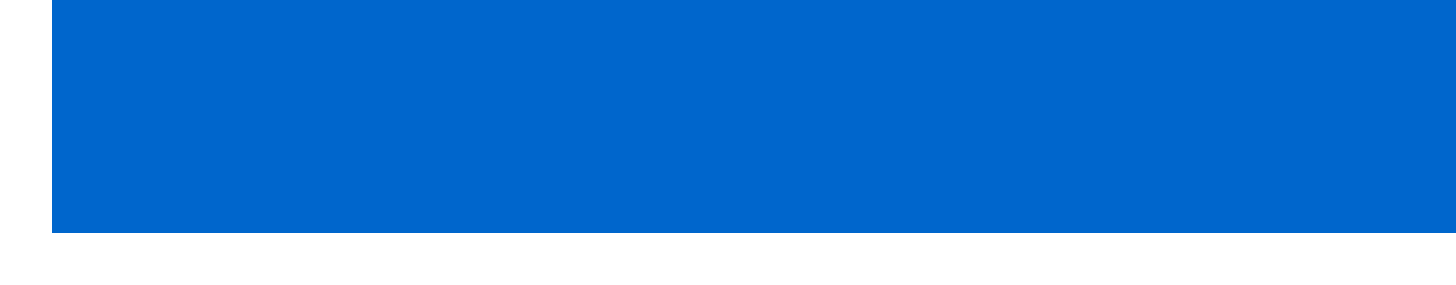What is the date of the meeting? The meeting took place on May 15, 2023.
Answer: May 15, 2023 Who is the chair of the meeting? The chair of the meeting is Jake Sullivan.
Answer: Jake Sullivan What are the team name suggestions discussed? The team name suggestions mentioned are 'Homerun Heroes' or 'Alma Mater Sluggers'.
Answer: 'Homerun Heroes' or 'Alma Mater Sluggers' What is the fundraising goal for the first year? The document states that the fundraising goal for the first year is $10,000.
Answer: $10,000 Who is responsible for creating social media accounts for the team? The document indicates that Emily Rodriguez is assigned to create social media accounts for the team.
Answer: Emily Rodriguez What is the projected annual expense for the team? The document mentions projected annual expenses amounting to $5,000.
Answer: $5,000 When is the next meeting scheduled? According to the document, the next meeting is scheduled for June 5, 2023.
Answer: June 5, 2023 What is one of the fundraising ideas proposed? The document includes hosting a 'Taste of Home' food festival as one of the fundraising ideas.
Answer: 'Taste of Home' food festival What equipment needs were identified for the team? The meeting noted that the team needs bats, balls, and uniforms with nostalgic college colors.
Answer: Bats, balls, and uniforms with nostalgic college colors 